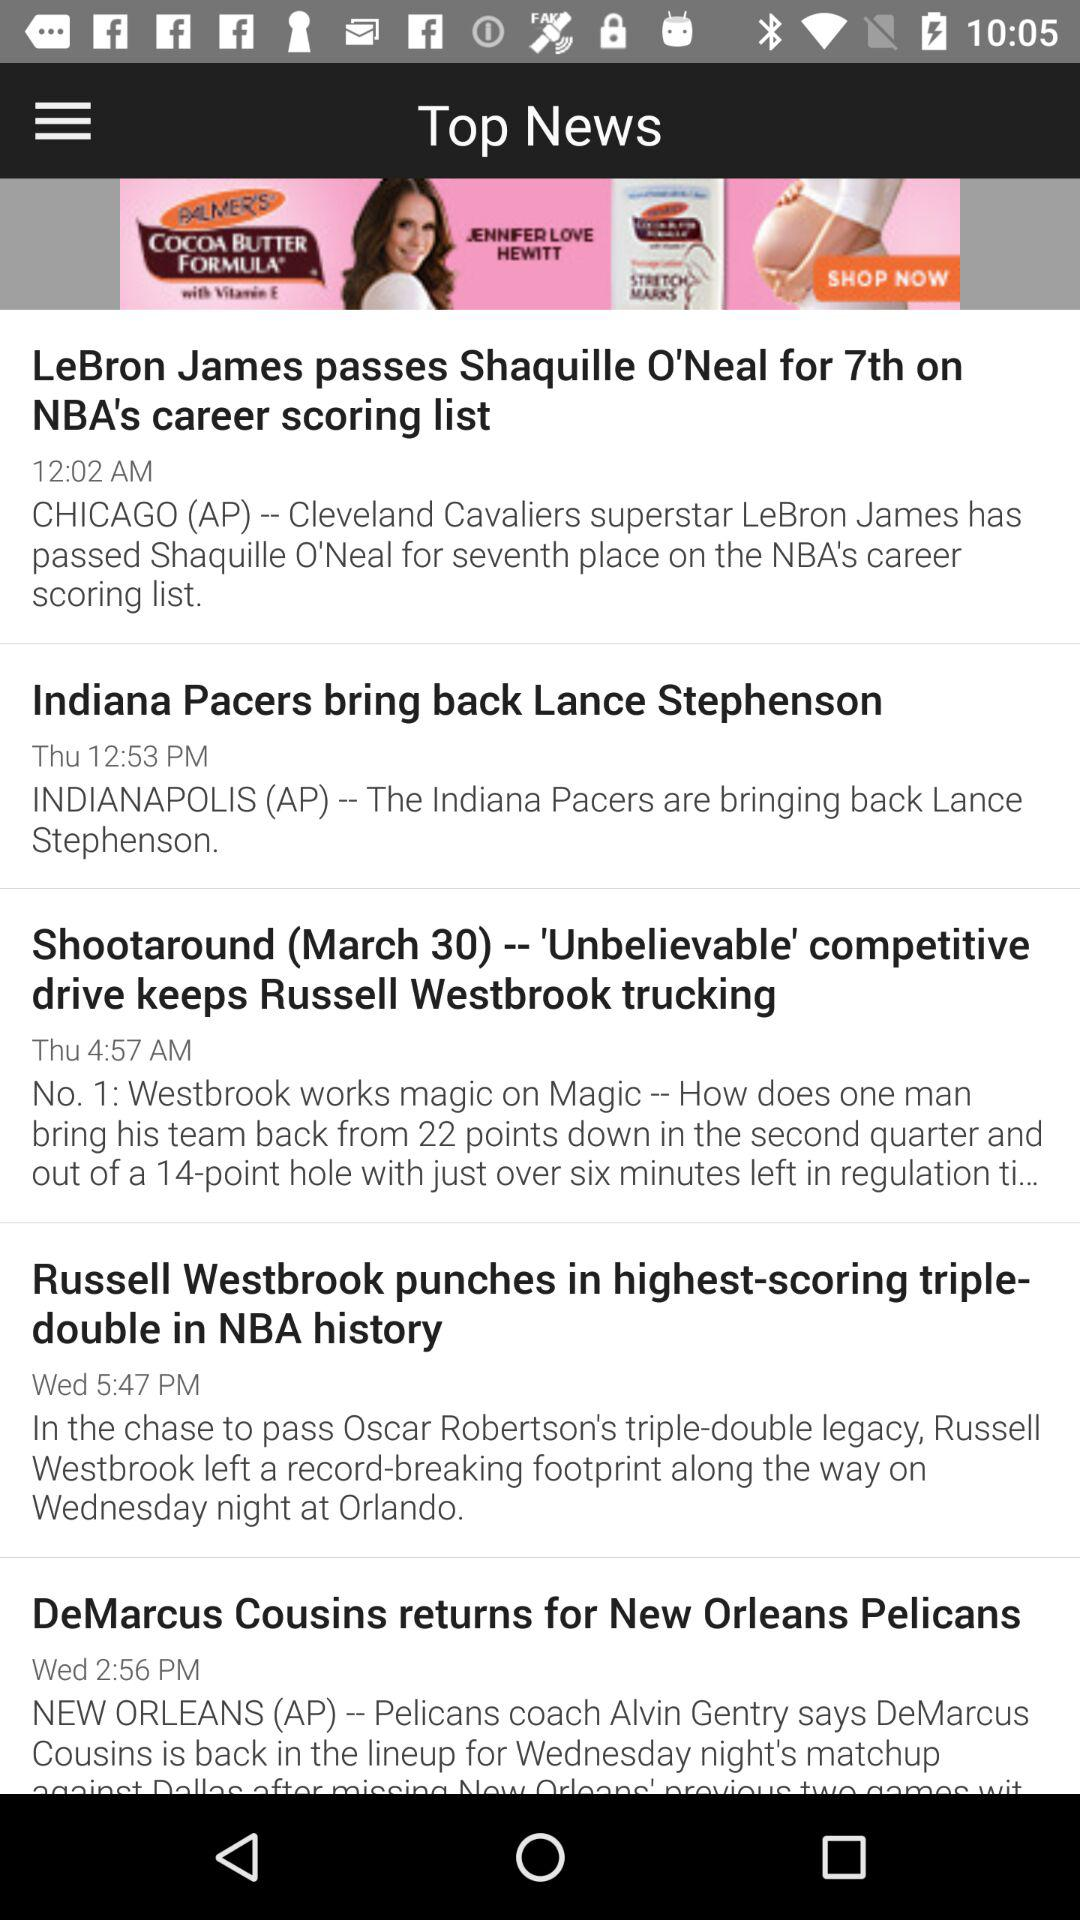What is the news on Wednesday at 2:56 PM? The news is "DeMarcus Cousins returns for New Orleans Pelicans". 